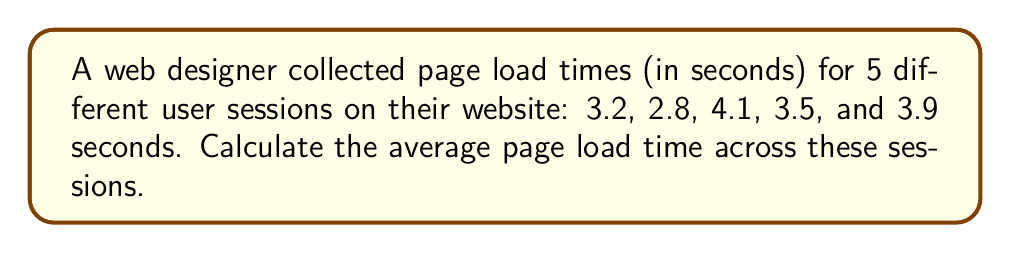Show me your answer to this math problem. To calculate the average page load time, we need to follow these steps:

1. Sum up all the load times:
   $$3.2 + 2.8 + 4.1 + 3.5 + 3.9 = 17.5\text{ seconds}$$

2. Count the total number of sessions:
   $$n = 5\text{ sessions}$$

3. Apply the formula for arithmetic mean (average):
   $$\text{Average} = \frac{\text{Sum of all values}}{\text{Number of values}}$$

4. Substitute the values:
   $$\text{Average} = \frac{17.5}{5} = 3.5\text{ seconds}$$

Therefore, the average page load time across the 5 user sessions is 3.5 seconds.
Answer: $3.5\text{ seconds}$ 